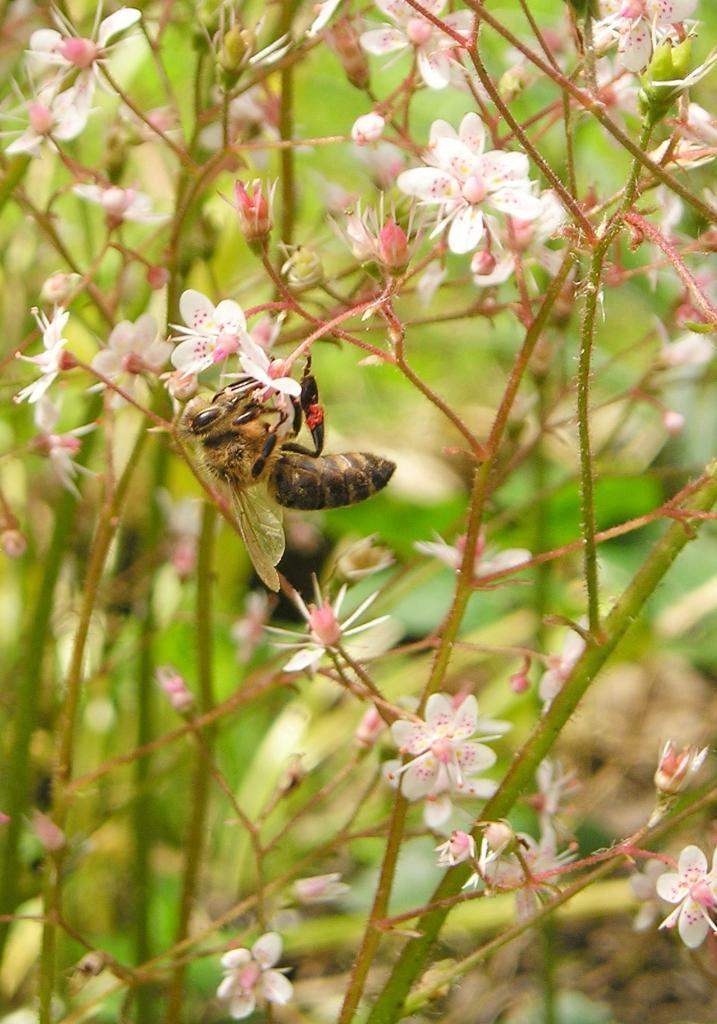What is the main subject in the center of the picture? There is a fly in the center of the picture. What type of plants can be seen in the image? There are flowers and some buds in the image. What else can be seen in the background of the image? There are other objects visible in the background of the image. What type of cake is being served in the image? There is no cake present in the image; it features a fly and flowers. What sense is being stimulated by the fly in the image? The image does not provide information about which sense is being stimulated by the fly. 